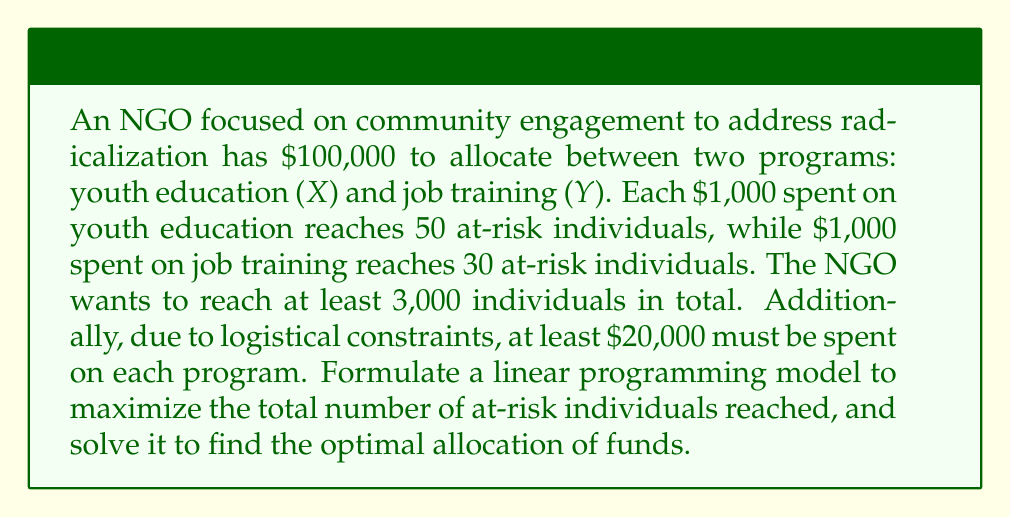Could you help me with this problem? Let's approach this step-by-step:

1) Define variables:
   $X$ = thousands of dollars spent on youth education
   $Y$ = thousands of dollars spent on job training

2) Objective function:
   Maximize $Z = 50X + 30Y$ (total individuals reached)

3) Constraints:
   a) Budget constraint: $X + Y \leq 100$
   b) Minimum reach: $50X + 30Y \geq 3000$
   c) Minimum spending on each program: $X \geq 20$ and $Y \geq 20$
   d) Non-negativity: $X \geq 0$ and $Y \geq 0$

4) The linear programming model:

   Maximize $Z = 50X + 30Y$
   Subject to:
   $X + Y \leq 100$
   $50X + 30Y \geq 3000$
   $X \geq 20$
   $Y \geq 20$
   $X, Y \geq 0$

5) To solve this, we can use the graphical method:

   [asy]
   import geometry;

   size(200);
   
   xlimits(0, 120);
   ylimits(0, 120);
   
   xaxis("X", Arrow);
   yaxis("Y", Arrow);
   
   path budget = (0,100)--(100,0);
   path reach = (60,0)--(0,100);
   path minX = (20,0)--(20,120);
   path minY = (0,20)--(120,20);
   
   draw(budget, blue);
   draw(reach, red);
   draw(minX, green);
   draw(minY, green);
   
   label("Budget", (50,55), N, blue);
   label("Minimum reach", (30,80), NW, red);
   label("Min X", (20,110), W, green);
   label("Min Y", (110,20), S, green);
   
   dot((60,40));
   label("Optimal point (60,40)", (60,40), SE);
   [/asy]

6) The feasible region is the area bounded by these constraints. The optimal solution will be at one of the corner points of this region.

7) Evaluating the objective function at each corner point:
   (20,20): $Z = 50(20) + 30(20) = 1600$
   (20,80): $Z = 50(20) + 30(80) = 3400$
   (60,40): $Z = 50(60) + 30(40) = 4200$

8) The maximum value of Z occurs at (60,40).

Therefore, the optimal allocation is $60,000 for youth education and $40,000 for job training, reaching a total of 4,200 at-risk individuals.
Answer: Optimal allocation: $X = 60$ (thousand dollars), $Y = 40$ (thousand dollars)
Maximum number of at-risk individuals reached: 4,200 